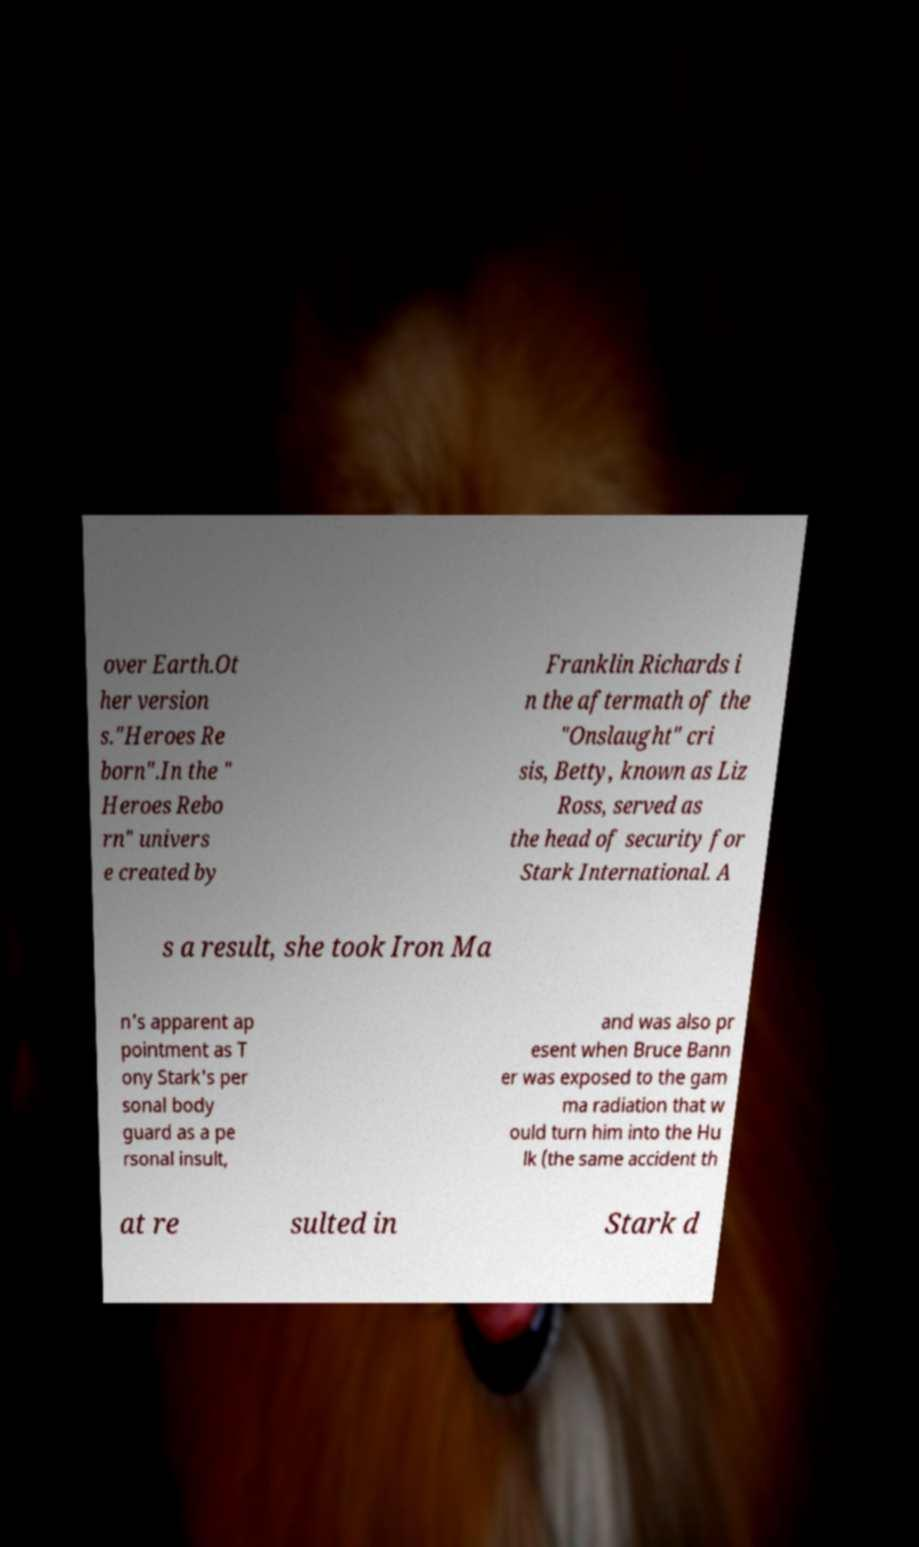Could you extract and type out the text from this image? over Earth.Ot her version s."Heroes Re born".In the " Heroes Rebo rn" univers e created by Franklin Richards i n the aftermath of the "Onslaught" cri sis, Betty, known as Liz Ross, served as the head of security for Stark International. A s a result, she took Iron Ma n's apparent ap pointment as T ony Stark's per sonal body guard as a pe rsonal insult, and was also pr esent when Bruce Bann er was exposed to the gam ma radiation that w ould turn him into the Hu lk (the same accident th at re sulted in Stark d 